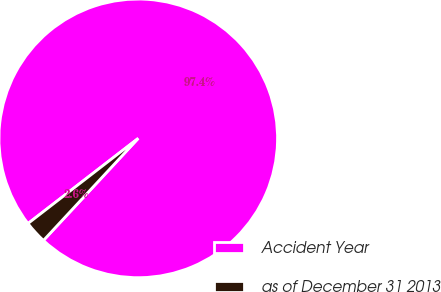<chart> <loc_0><loc_0><loc_500><loc_500><pie_chart><fcel>Accident Year<fcel>as of December 31 2013<nl><fcel>97.38%<fcel>2.62%<nl></chart> 